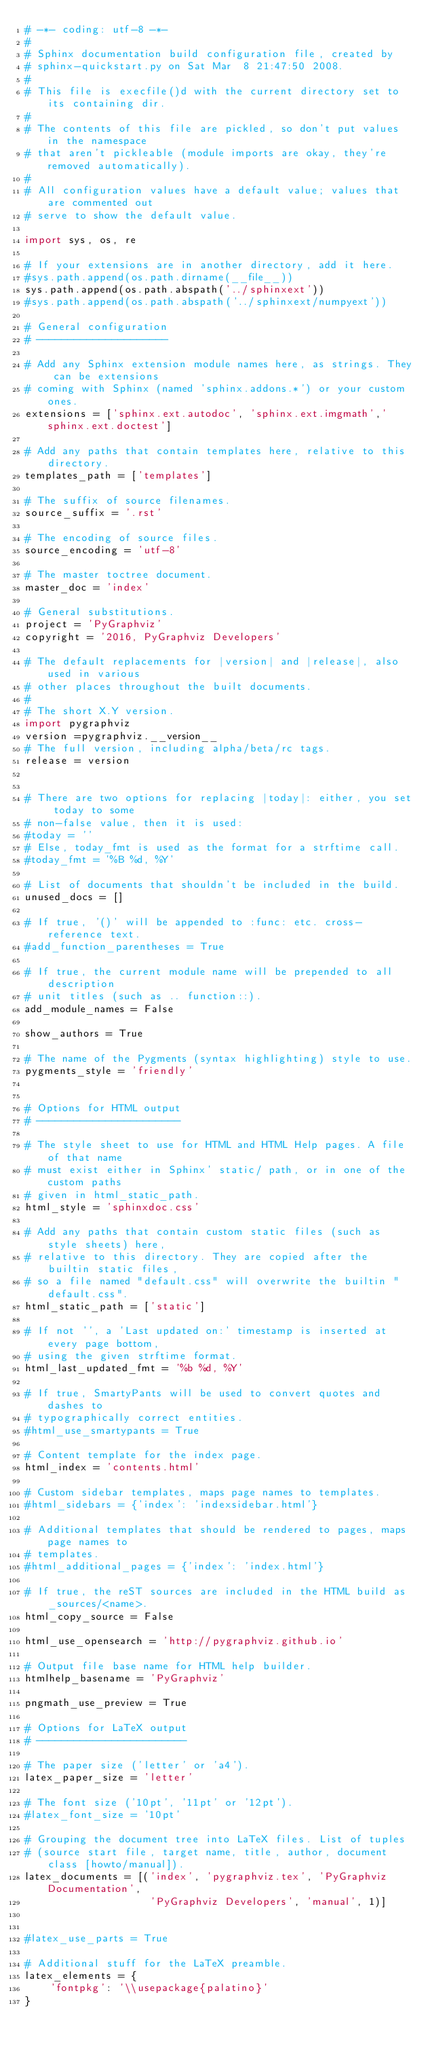Convert code to text. <code><loc_0><loc_0><loc_500><loc_500><_Python_># -*- coding: utf-8 -*-
#
# Sphinx documentation build configuration file, created by
# sphinx-quickstart.py on Sat Mar  8 21:47:50 2008.
#
# This file is execfile()d with the current directory set to its containing dir.
#
# The contents of this file are pickled, so don't put values in the namespace
# that aren't pickleable (module imports are okay, they're removed automatically).
#
# All configuration values have a default value; values that are commented out
# serve to show the default value.

import sys, os, re

# If your extensions are in another directory, add it here.
#sys.path.append(os.path.dirname(__file__))
sys.path.append(os.path.abspath('../sphinxext'))
#sys.path.append(os.path.abspath('../sphinxext/numpyext'))

# General configuration
# ---------------------

# Add any Sphinx extension module names here, as strings. They can be extensions
# coming with Sphinx (named 'sphinx.addons.*') or your custom ones.
extensions = ['sphinx.ext.autodoc', 'sphinx.ext.imgmath','sphinx.ext.doctest']

# Add any paths that contain templates here, relative to this directory.
templates_path = ['templates']

# The suffix of source filenames.
source_suffix = '.rst'

# The encoding of source files.                                      
source_encoding = 'utf-8'

# The master toctree document.
master_doc = 'index'

# General substitutions.
project = 'PyGraphviz'
copyright = '2016, PyGraphviz Developers'

# The default replacements for |version| and |release|, also used in various
# other places throughout the built documents.
#
# The short X.Y version.
import pygraphviz
version =pygraphviz.__version__
# The full version, including alpha/beta/rc tags.
release = version


# There are two options for replacing |today|: either, you set today to some
# non-false value, then it is used:
#today = ''
# Else, today_fmt is used as the format for a strftime call.
#today_fmt = '%B %d, %Y'

# List of documents that shouldn't be included in the build.
unused_docs = []

# If true, '()' will be appended to :func: etc. cross-reference text.
#add_function_parentheses = True

# If true, the current module name will be prepended to all description
# unit titles (such as .. function::).
add_module_names = False

show_authors = True

# The name of the Pygments (syntax highlighting) style to use.
pygments_style = 'friendly'


# Options for HTML output
# -----------------------

# The style sheet to use for HTML and HTML Help pages. A file of that name
# must exist either in Sphinx' static/ path, or in one of the custom paths
# given in html_static_path.
html_style = 'sphinxdoc.css'

# Add any paths that contain custom static files (such as style sheets) here,
# relative to this directory. They are copied after the builtin static files,
# so a file named "default.css" will overwrite the builtin "default.css".
html_static_path = ['static']

# If not '', a 'Last updated on:' timestamp is inserted at every page bottom,
# using the given strftime format.
html_last_updated_fmt = '%b %d, %Y'

# If true, SmartyPants will be used to convert quotes and dashes to
# typographically correct entities.
#html_use_smartypants = True

# Content template for the index page.
html_index = 'contents.html'

# Custom sidebar templates, maps page names to templates.
#html_sidebars = {'index': 'indexsidebar.html'}

# Additional templates that should be rendered to pages, maps page names to
# templates.
#html_additional_pages = {'index': 'index.html'}

# If true, the reST sources are included in the HTML build as _sources/<name>.
html_copy_source = False

html_use_opensearch = 'http://pygraphviz.github.io'

# Output file base name for HTML help builder.
htmlhelp_basename = 'PyGraphviz'

pngmath_use_preview = True

# Options for LaTeX output
# ------------------------

# The paper size ('letter' or 'a4').
latex_paper_size = 'letter'

# The font size ('10pt', '11pt' or '12pt').
#latex_font_size = '10pt'

# Grouping the document tree into LaTeX files. List of tuples
# (source start file, target name, title, author, document class [howto/manual]).
latex_documents = [('index', 'pygraphviz.tex', 'PyGraphviz Documentation',
                    'PyGraphviz Developers', 'manual', 1)]


#latex_use_parts = True

# Additional stuff for the LaTeX preamble.
latex_elements = {
    'fontpkg': '\\usepackage{palatino}'
}
</code> 